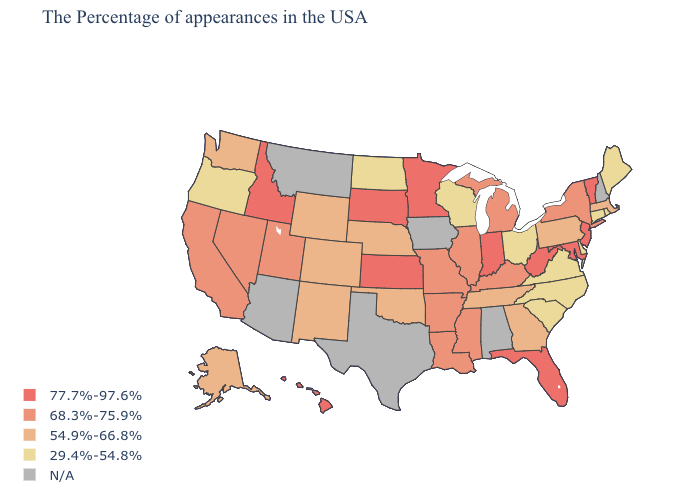What is the highest value in states that border Connecticut?
Quick response, please. 68.3%-75.9%. Which states have the lowest value in the USA?
Be succinct. Maine, Rhode Island, Connecticut, Delaware, Virginia, North Carolina, South Carolina, Ohio, Wisconsin, North Dakota, Oregon. Among the states that border New Mexico , does Utah have the lowest value?
Short answer required. No. Does the first symbol in the legend represent the smallest category?
Be succinct. No. What is the value of Connecticut?
Be succinct. 29.4%-54.8%. What is the value of Maryland?
Give a very brief answer. 77.7%-97.6%. What is the highest value in the USA?
Be succinct. 77.7%-97.6%. What is the highest value in the Northeast ?
Short answer required. 77.7%-97.6%. What is the lowest value in states that border Washington?
Short answer required. 29.4%-54.8%. What is the value of North Carolina?
Write a very short answer. 29.4%-54.8%. What is the lowest value in the USA?
Short answer required. 29.4%-54.8%. What is the value of Florida?
Give a very brief answer. 77.7%-97.6%. Among the states that border Kentucky , which have the lowest value?
Short answer required. Virginia, Ohio. Is the legend a continuous bar?
Answer briefly. No. Name the states that have a value in the range 77.7%-97.6%?
Short answer required. Vermont, New Jersey, Maryland, West Virginia, Florida, Indiana, Minnesota, Kansas, South Dakota, Idaho, Hawaii. 